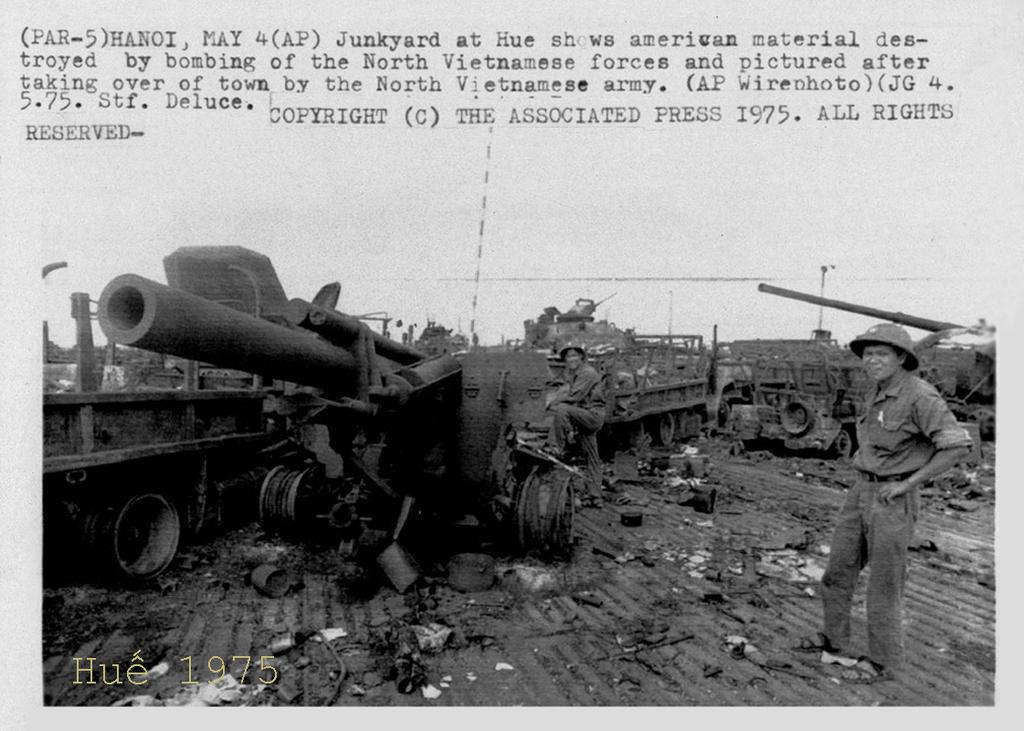<image>
Present a compact description of the photo's key features. Old photo from Vietnam war shows a destroyed material as a vietnamese soldier stands near by. 